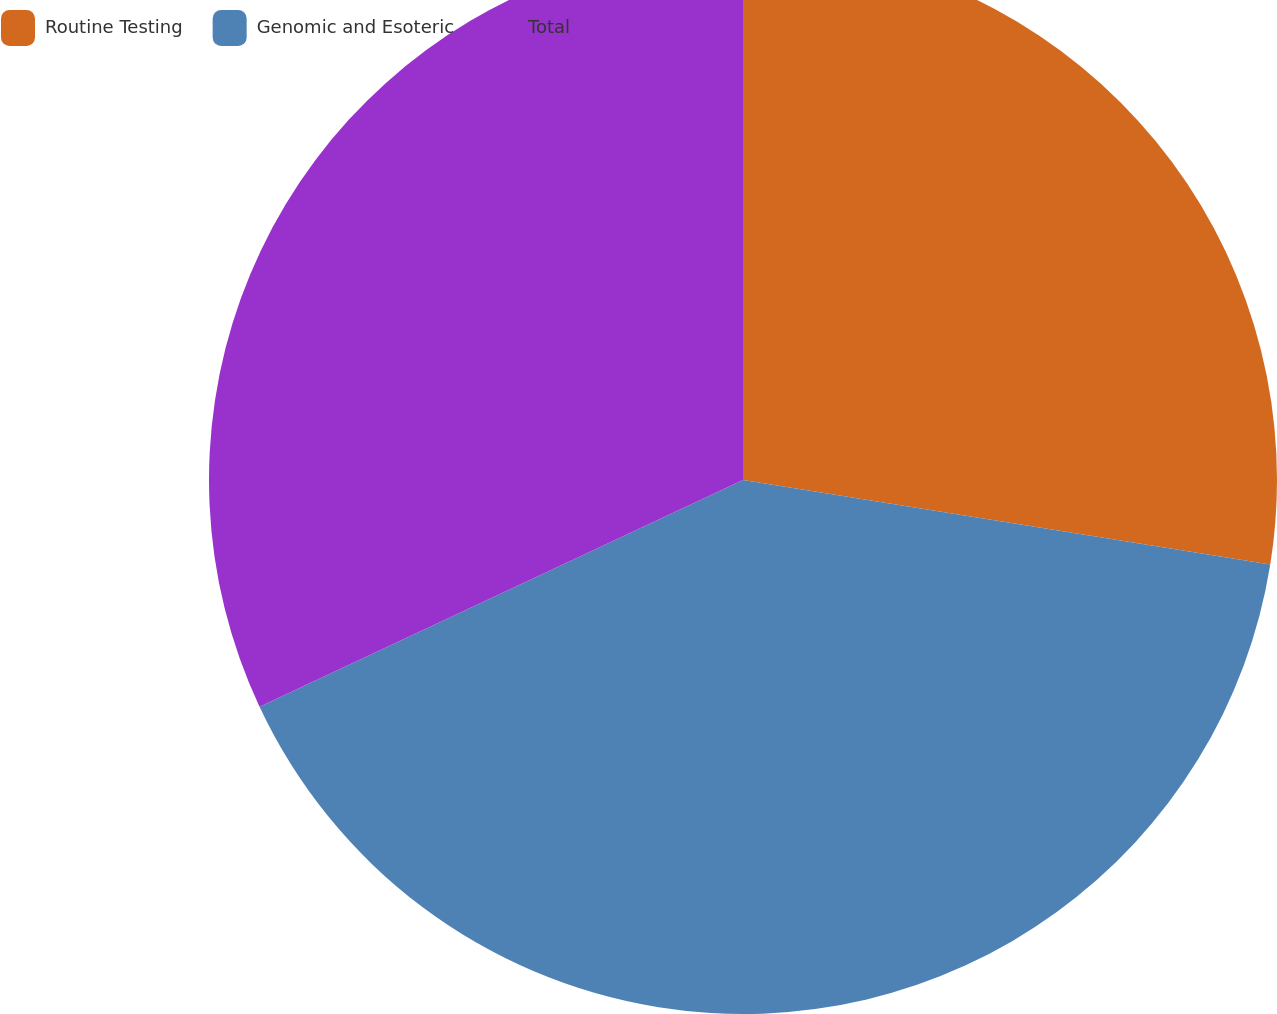Convert chart to OTSL. <chart><loc_0><loc_0><loc_500><loc_500><pie_chart><fcel>Routine Testing<fcel>Genomic and Esoteric<fcel>Total<nl><fcel>27.53%<fcel>40.49%<fcel>31.98%<nl></chart> 